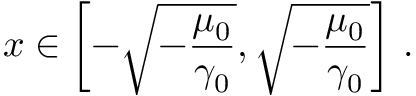<formula> <loc_0><loc_0><loc_500><loc_500>x \in \left [ - \sqrt { - \frac { \mu _ { 0 } } { \gamma _ { 0 } } } , \sqrt { - \frac { \mu _ { 0 } } { \gamma _ { 0 } } } \right ] \, .</formula> 